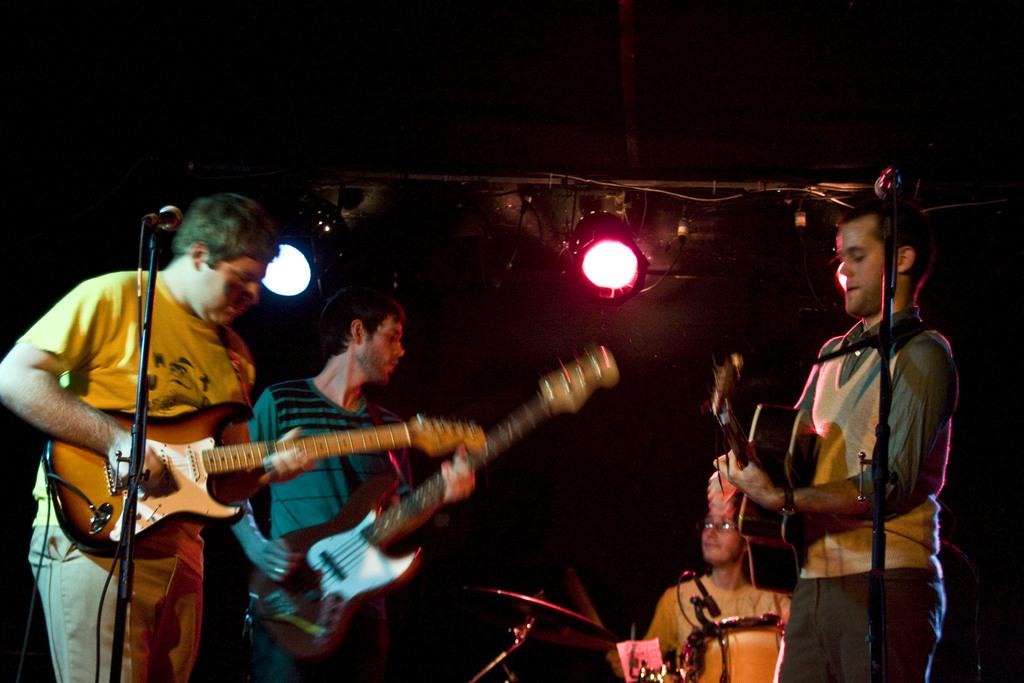How many people are in the image? There are three persons in the image. What are the persons doing in the image? The persons are playing guitar. What objects are present in the image that are related to sound amplification? There are microphones in the image. Can you describe any light source in the image? Yes, there is a light in the image. What type of objects are present in the image that are related to music? There are musical instruments in the image. What type of theory is being discussed in the image? There is no indication in the image that a theory is being discussed. Can you see a church in the image? No, there is no church present in the image. 